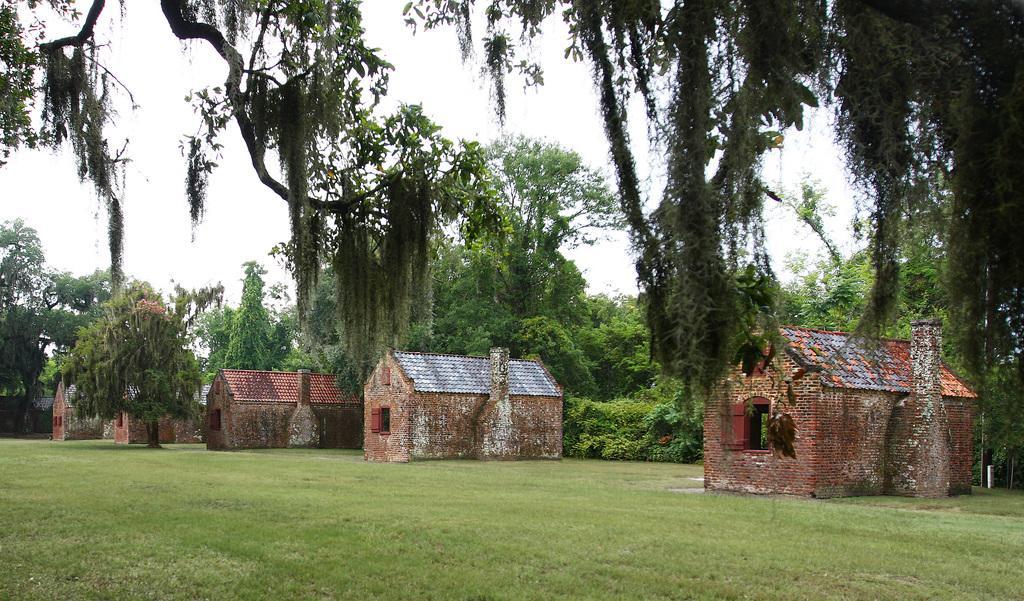How would you summarize this image in a sentence or two? In the center of the image there are sheds. At the bottom we can see grass. In the background there are trees and sky. 